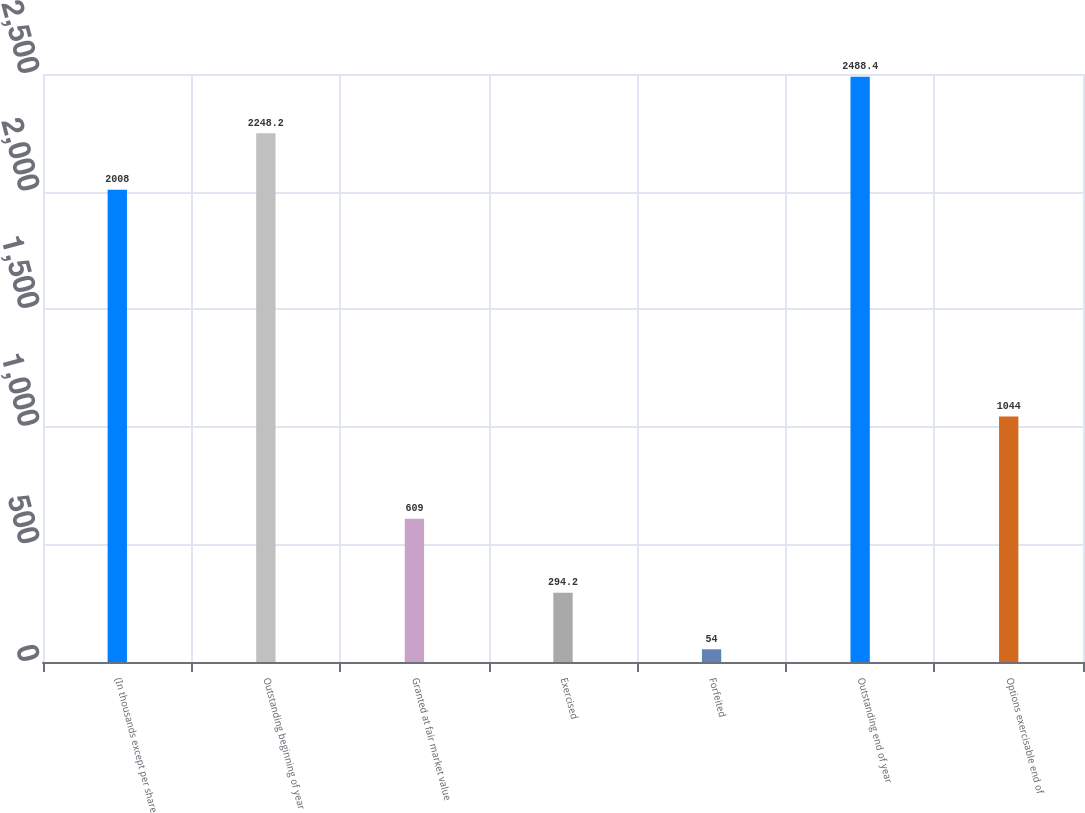Convert chart. <chart><loc_0><loc_0><loc_500><loc_500><bar_chart><fcel>(In thousands except per share<fcel>Outstanding beginning of year<fcel>Granted at fair market value<fcel>Exercised<fcel>Forfeited<fcel>Outstanding end of year<fcel>Options exercisable end of<nl><fcel>2008<fcel>2248.2<fcel>609<fcel>294.2<fcel>54<fcel>2488.4<fcel>1044<nl></chart> 